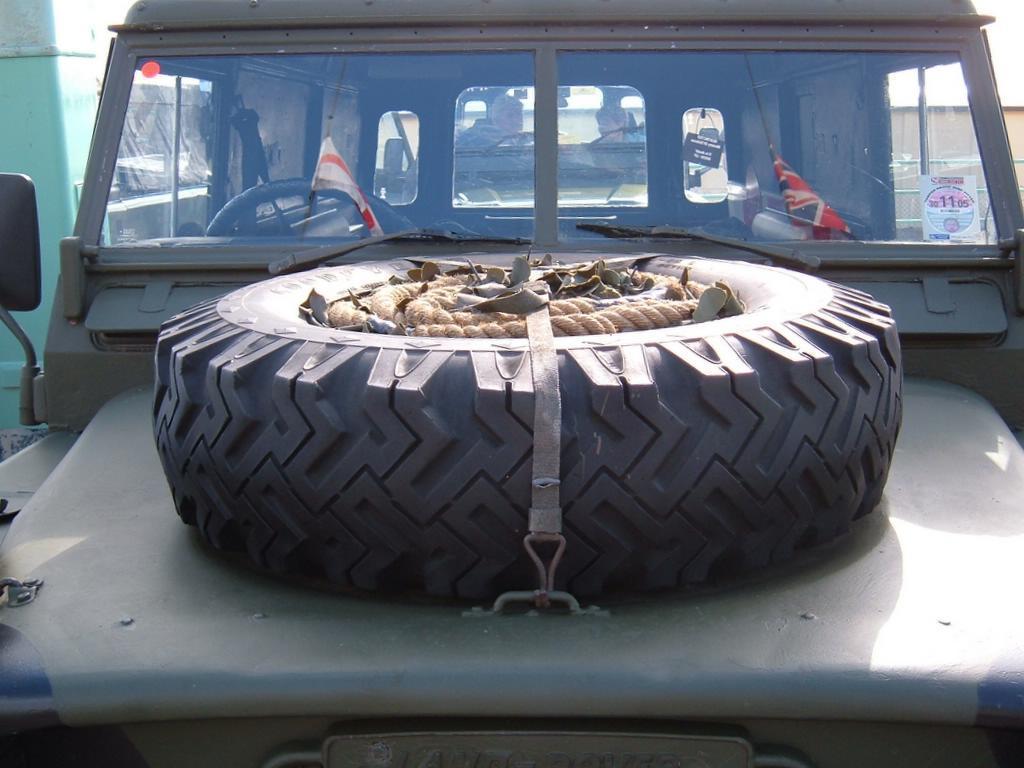Can you describe this image briefly? In this image there is a jeep. Inside the jeep there are two flags, steering and on top of the jeep there is a tyre with a rope and at the back side there is a building. 